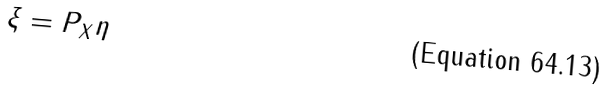<formula> <loc_0><loc_0><loc_500><loc_500>\xi = P _ { X } \eta</formula> 